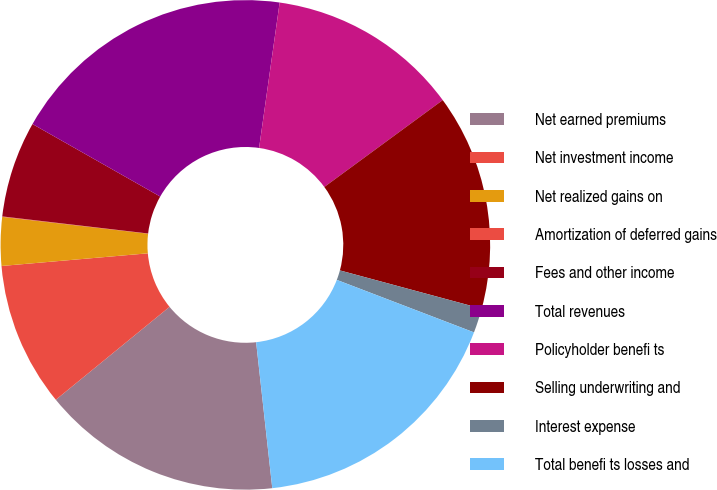Convert chart to OTSL. <chart><loc_0><loc_0><loc_500><loc_500><pie_chart><fcel>Net earned premiums<fcel>Net investment income<fcel>Net realized gains on<fcel>Amortization of deferred gains<fcel>Fees and other income<fcel>Total revenues<fcel>Policyholder benefi ts<fcel>Selling underwriting and<fcel>Interest expense<fcel>Total benefi ts losses and<nl><fcel>15.85%<fcel>9.53%<fcel>3.2%<fcel>0.03%<fcel>6.36%<fcel>19.02%<fcel>12.69%<fcel>14.27%<fcel>1.62%<fcel>17.43%<nl></chart> 